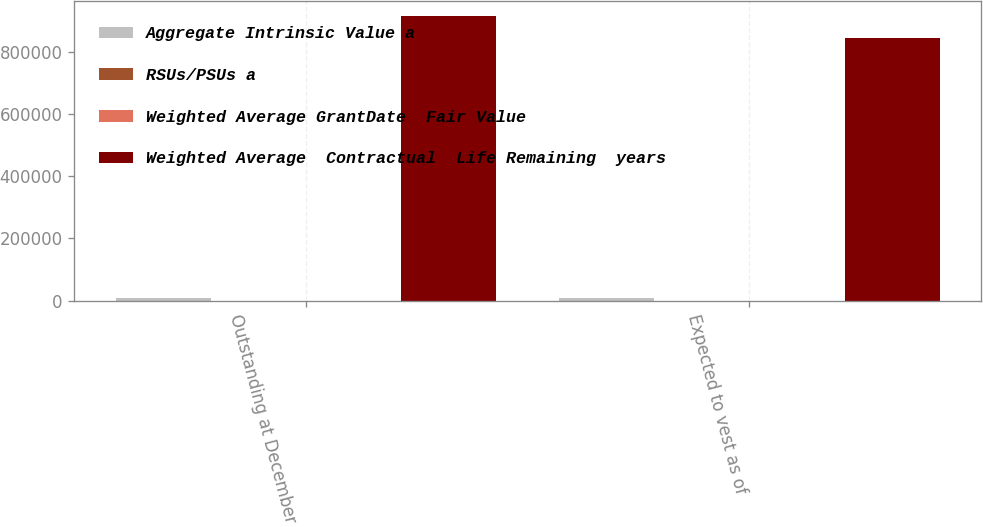<chart> <loc_0><loc_0><loc_500><loc_500><stacked_bar_chart><ecel><fcel>Outstanding at December 26<fcel>Expected to vest as of<nl><fcel>Aggregate Intrinsic Value a<fcel>9108<fcel>8389<nl><fcel>RSUs/PSUs a<fcel>84.03<fcel>83.52<nl><fcel>Weighted Average GrantDate  Fair Value<fcel>1.29<fcel>1.21<nl><fcel>Weighted Average  Contractual  Life Remaining  years<fcel>915727<fcel>843472<nl></chart> 